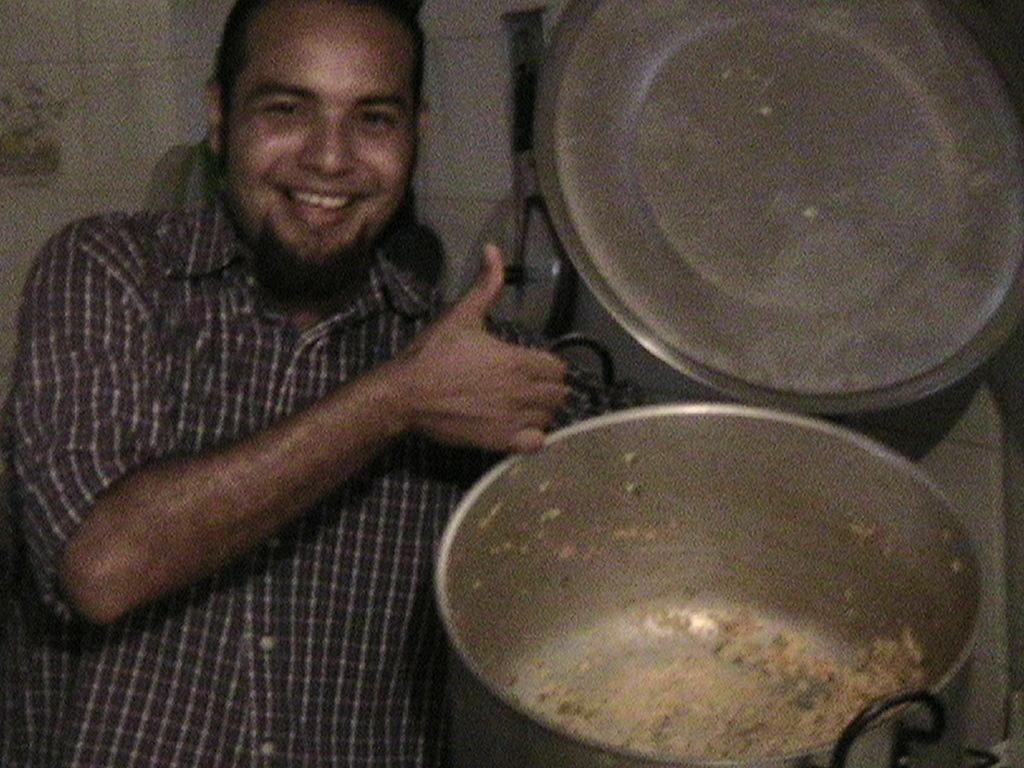Who is present in the image? There is a man in the image. What is the man holding in the image? The man is holding a vessel. What is the status of the vessel's cap? The vessel's cap is open. What can be found inside the vessel? There is food inside the vessel. How many dogs are present in the image? There are no dogs present in the image. What type of flock can be seen flying in the background of the image? There is no flock or background visible in the image, as it only features a man holding a vessel with an open cap and food inside. 